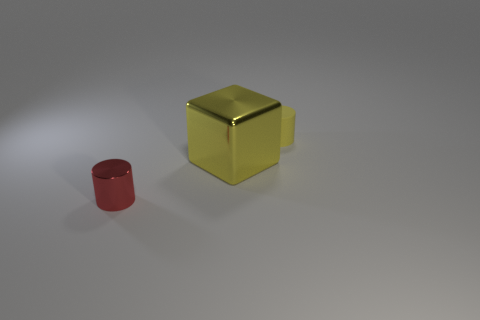Do the red thing and the tiny cylinder that is behind the red object have the same material?
Your response must be concise. No. Are any large rubber balls visible?
Give a very brief answer. No. Are there any small cylinders behind the cylinder that is in front of the cylinder behind the yellow cube?
Your answer should be compact. Yes. How many small objects are either matte things or yellow things?
Your answer should be very brief. 1. The thing that is the same size as the yellow matte cylinder is what color?
Provide a succinct answer. Red. How many objects are on the left side of the tiny yellow object?
Your answer should be very brief. 2. Are there any tiny yellow objects that have the same material as the yellow cylinder?
Make the answer very short. No. What is the shape of the thing that is the same color as the big metal cube?
Your response must be concise. Cylinder. What color is the cylinder that is right of the shiny block?
Your response must be concise. Yellow. Are there an equal number of tiny cylinders that are behind the red cylinder and metallic things to the right of the big metallic object?
Offer a terse response. No. 